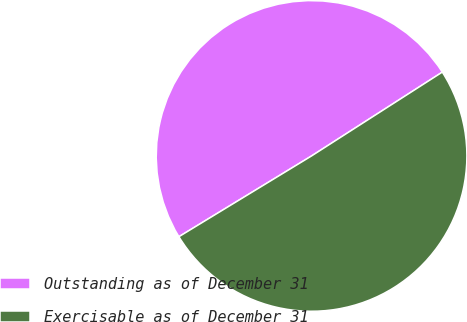<chart> <loc_0><loc_0><loc_500><loc_500><pie_chart><fcel>Outstanding as of December 31<fcel>Exercisable as of December 31<nl><fcel>49.63%<fcel>50.37%<nl></chart> 